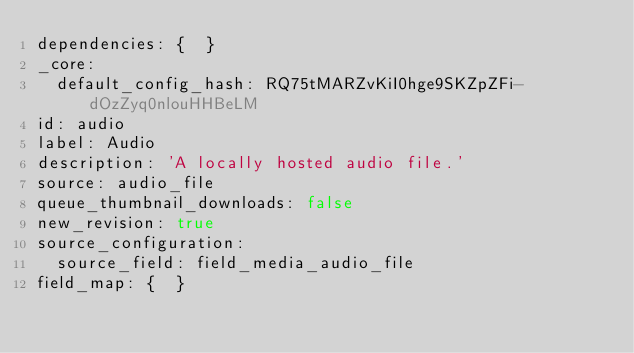<code> <loc_0><loc_0><loc_500><loc_500><_YAML_>dependencies: {  }
_core:
  default_config_hash: RQ75tMARZvKiI0hge9SKZpZFi-dOzZyq0nlouHHBeLM
id: audio
label: Audio
description: 'A locally hosted audio file.'
source: audio_file
queue_thumbnail_downloads: false
new_revision: true
source_configuration:
  source_field: field_media_audio_file
field_map: {  }
</code> 